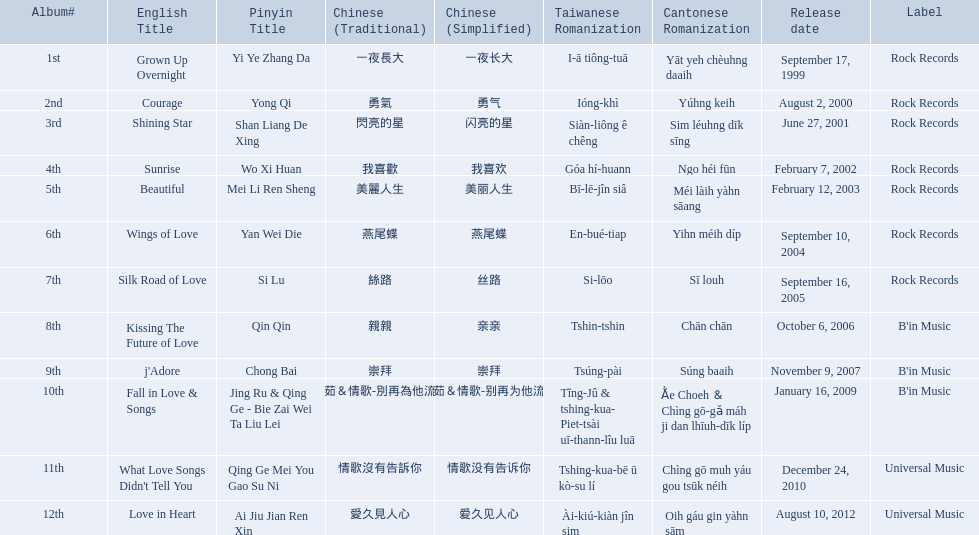What were the albums? Grown Up Overnight, Courage, Shining Star, Sunrise, Beautiful, Wings of Love, Silk Road of Love, Kissing The Future of Love, j'Adore, Fall in Love & Songs, What Love Songs Didn't Tell You, Love in Heart. Which ones were released by b'in music? Kissing The Future of Love, j'Adore. Of these, which one was in an even-numbered year? Kissing The Future of Love. 